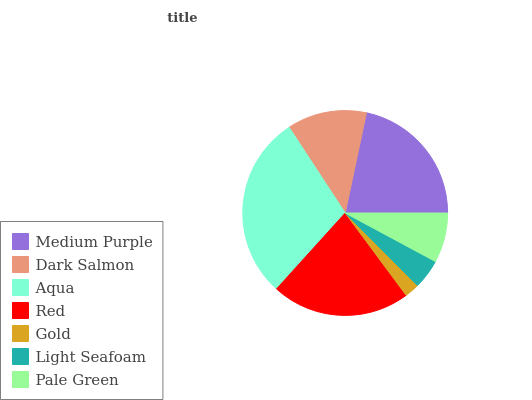Is Gold the minimum?
Answer yes or no. Yes. Is Aqua the maximum?
Answer yes or no. Yes. Is Dark Salmon the minimum?
Answer yes or no. No. Is Dark Salmon the maximum?
Answer yes or no. No. Is Medium Purple greater than Dark Salmon?
Answer yes or no. Yes. Is Dark Salmon less than Medium Purple?
Answer yes or no. Yes. Is Dark Salmon greater than Medium Purple?
Answer yes or no. No. Is Medium Purple less than Dark Salmon?
Answer yes or no. No. Is Dark Salmon the high median?
Answer yes or no. Yes. Is Dark Salmon the low median?
Answer yes or no. Yes. Is Aqua the high median?
Answer yes or no. No. Is Light Seafoam the low median?
Answer yes or no. No. 